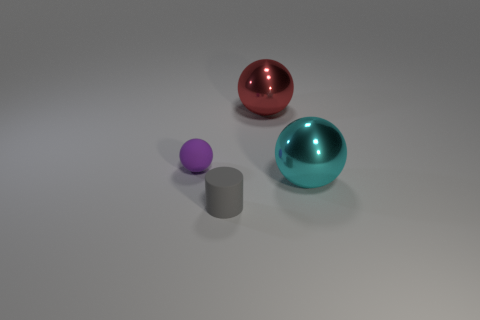Is there anything else that is the same shape as the small gray object?
Give a very brief answer. No. Are there the same number of objects behind the cyan ball and tiny purple rubber cylinders?
Make the answer very short. No. Is the size of the metal sphere that is on the right side of the red sphere the same as the small gray matte object?
Keep it short and to the point. No. There is a ball that is the same size as the gray cylinder; what color is it?
Keep it short and to the point. Purple. Is there a matte object left of the matte thing behind the metallic sphere that is in front of the tiny purple thing?
Provide a short and direct response. No. There is a tiny thing in front of the purple thing; what is it made of?
Your response must be concise. Rubber. There is a red object; is it the same shape as the rubber thing that is behind the big cyan sphere?
Keep it short and to the point. Yes. Are there an equal number of gray matte cylinders that are behind the small gray matte object and large metal things behind the big red object?
Ensure brevity in your answer.  Yes. How many other things are made of the same material as the small purple ball?
Ensure brevity in your answer.  1. What number of metallic things are either big gray balls or spheres?
Provide a succinct answer. 2. 